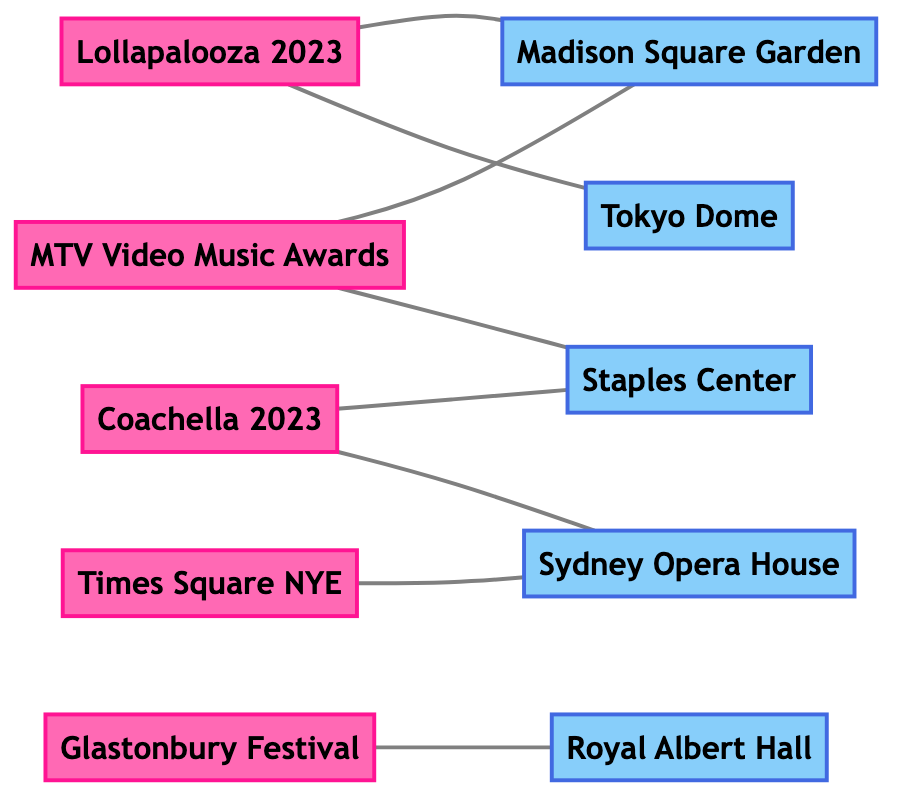What's the total number of events shown in the diagram? The diagram lists five nodes labeled as events: Lollapalooza 2023, Coachella 2023, MTV Video Music Awards, Glastonbury Festival, and Times Square NYE. Counting these gives a total of 5 events.
Answer: 5 Which location is connected to Lollapalooza 2023? In the diagram, Lollapalooza 2023 is connected by an edge to Madison Square Garden and Tokyo Dome. Therefore, the immediate connections to Lollapalooza 2023 are those two locations.
Answer: Madison Square Garden, Tokyo Dome How many edges are there in the diagram? The diagram shows connections between events and locations. By counting the edges, we find there are 8 connections in total: Lollapalooza 2023 to Madison Square Garden, Coachella 2023 to Staples Center, MTV Video Music Awards to Madison Square Garden, Glastonbury Festival to Royal Albert Hall, Times Square NYE to Sydney Opera House, and three others.
Answer: 8 Which event is associated with the Royal Albert Hall? The diagram indicates that Glastonbury Festival is connected to Royal Albert Hall. This indicates that the event associated with that specific location is Glastonbury Festival.
Answer: Glastonbury Festival Are there any locations that are connected to multiple events? Upon reviewing the edges, both Madison Square Garden and Sydney Opera House are connected to multiple events: Madison Square Garden connects to Lollapalooza 2023 and MTV Video Music Awards, while Sydney Opera House connects to Times Square NYE and Coachella 2023. Hence, both locations have multiple associations.
Answer: Madison Square Garden, Sydney Opera House Which event would you find at the Staples Center? The diagram clearly shows that Coachella 2023 and MTV Video Music Awards are directly connected to Staples Center. This means both events can take place at this location.
Answer: Coachella 2023, MTV Video Music Awards What is the relationship between Times Square NYE and Sydney Opera House? In the diagram, Times Square NYE is connected to Sydney Opera House by an undirected edge, indicating that there is a direct relationship where these two events—Times Square NYE and the location, Sydney Opera House—are linked.
Answer: Connected How many locations are depicted in the diagram? Counting the nodes classified as locations reveals five, which include Madison Square Garden, Royal Albert Hall, Staples Center, Tokyo Dome, and Sydney Opera House. Thus, there are five unique locations depicted.
Answer: 5 